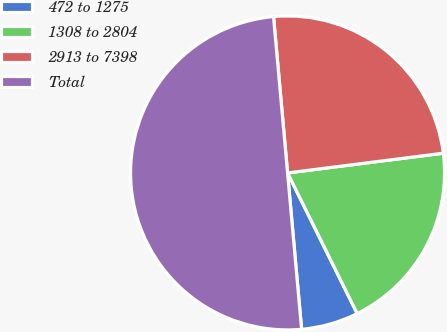Convert chart to OTSL. <chart><loc_0><loc_0><loc_500><loc_500><pie_chart><fcel>472 to 1275<fcel>1308 to 2804<fcel>2913 to 7398<fcel>Total<nl><fcel>5.89%<fcel>19.69%<fcel>24.42%<fcel>50.0%<nl></chart> 